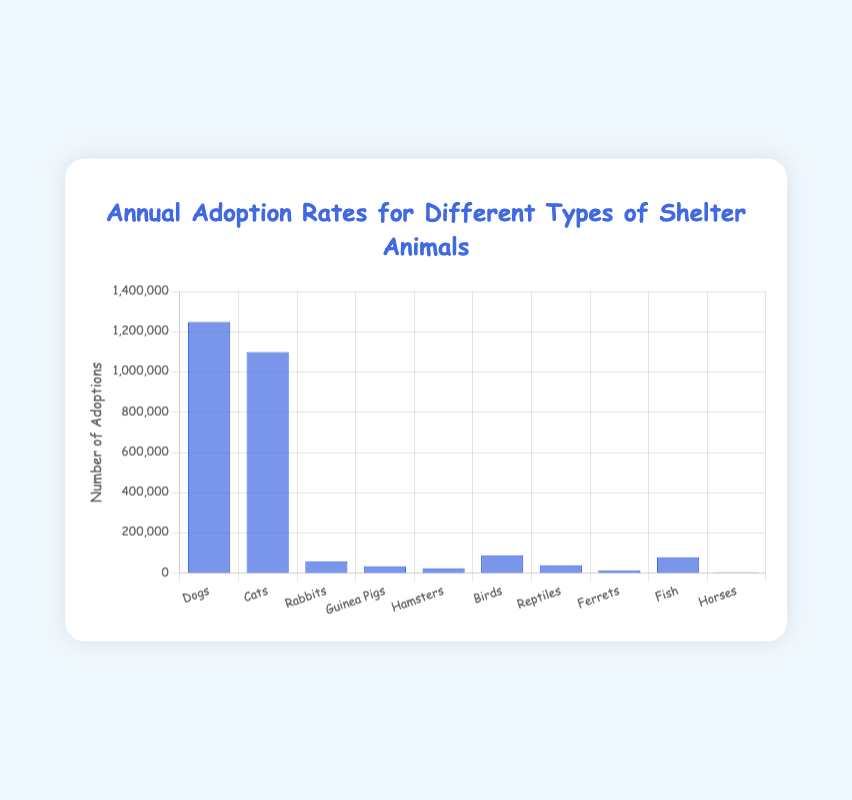Which type of shelter animal has the highest annual adoption rate? The bar chart displays the annual adoption rates for different shelter animals with the height of each bar representing the number of adoptions. The tallest bar corresponds to Dogs, indicating they have the highest adoption rate.
Answer: Dogs Which types of shelter animals have the lowest annual adoption rates? Observing the bar chart, the lowest bars represent the animals with the lowest adoption rates. Ferrets and Horses have the shortest bars, indicating they have the lowest adoption rates.
Answer: Ferrets and Horses What is the difference in annual adoption rates between Dogs and Cats? Looking at the heights of the bars, Dogs have 1,250,000 adoptions, and Cats have 1,100,000 adoptions. Subtracting the two gives 1,250,000 - 1,100,000 = 150,000.
Answer: 150,000 Which animal types have annual adoption rates between 50,000 and 100,000? By examining the heights of the bars, Birds and Fish fall within this range with adoption rates of 90,000 and 80,000 respectively.
Answer: Birds and Fish What is the total annual adoption rate for small mammals (Rabbits, Guinea Pigs, Hamsters)? Adding the annual adoption rates of Rabbits (60,000), Guinea Pigs (35,000), and Hamsters (25,000) gives a total of 60,000 + 35,000 + 25,000 = 120,000.
Answer: 120,000 How much more annual adoptions do Dogs have compared to Reptiles? Dogs have an adoption rate of 1,250,000 and Reptiles have 40,000. The difference is 1,250,000 - 40,000 = 1,210,000.
Answer: 1,210,000 What is the average annual adoption rate for Fish and Horses? To calculate the average, add the adoption rates of Fish (80,000) and Horses (5,000) and divide by 2: (80,000 + 5,000) / 2 = 42,500.
Answer: 42,500 Which animal type has twice the annual adoption rate of Reptiles? Reptiles have 40,000 annual adoptions. The animal with twice this rate would have 40,000 * 2 = 80,000 adoptions, which corresponds to Fish.
Answer: Fish 